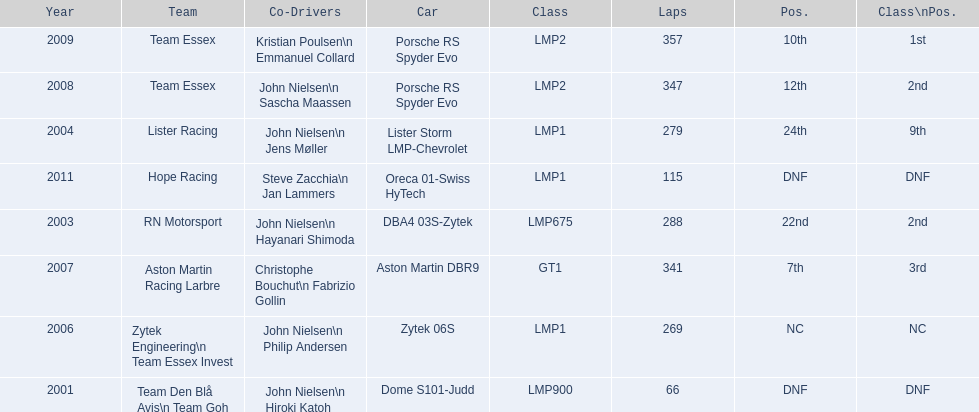In how many cases was the ultimate position over 20? 2. 